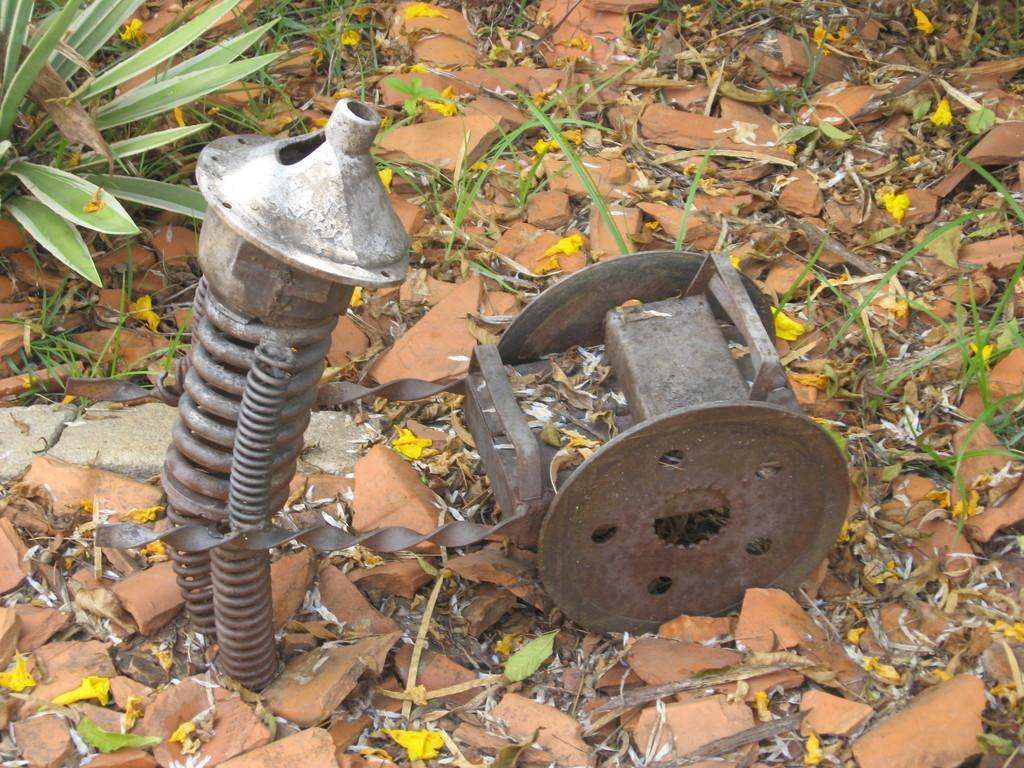In one or two sentences, can you explain what this image depicts? In this picture there are metal objects and there are plants. At the bottom there are stones and there are dried leaves. 